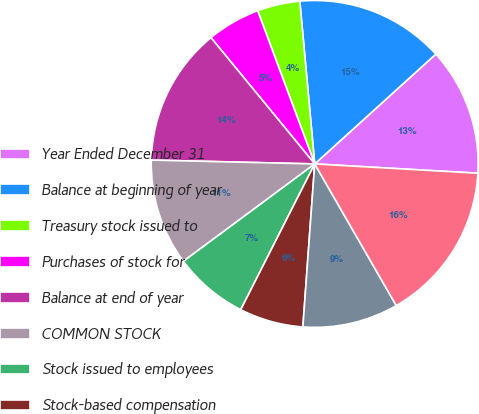Convert chart. <chart><loc_0><loc_0><loc_500><loc_500><pie_chart><fcel>Year Ended December 31<fcel>Balance at beginning of year<fcel>Treasury stock issued to<fcel>Purchases of stock for<fcel>Balance at end of year<fcel>COMMON STOCK<fcel>Stock issued to employees<fcel>Stock-based compensation<fcel>Net income attributable to<fcel>Dividends (per share - 156 148<nl><fcel>12.63%<fcel>14.73%<fcel>4.22%<fcel>5.27%<fcel>13.68%<fcel>10.53%<fcel>7.37%<fcel>6.32%<fcel>9.47%<fcel>15.78%<nl></chart> 